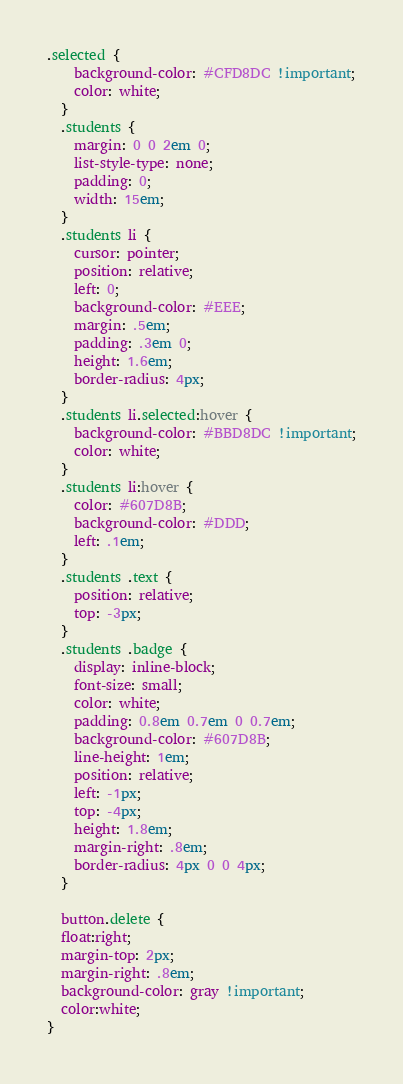<code> <loc_0><loc_0><loc_500><loc_500><_CSS_>.selected {
    background-color: #CFD8DC !important;
    color: white;
  }
  .students {
    margin: 0 0 2em 0;
    list-style-type: none;
    padding: 0;
    width: 15em;
  }
  .students li {
    cursor: pointer;
    position: relative;
    left: 0;
    background-color: #EEE;
    margin: .5em;
    padding: .3em 0;
    height: 1.6em;
    border-radius: 4px;
  }
  .students li.selected:hover {
    background-color: #BBD8DC !important;
    color: white;
  }
  .students li:hover {
    color: #607D8B;
    background-color: #DDD;
    left: .1em;
  }
  .students .text {
    position: relative;
    top: -3px;
  }
  .students .badge {
    display: inline-block;
    font-size: small;
    color: white;
    padding: 0.8em 0.7em 0 0.7em;
    background-color: #607D8B;
    line-height: 1em;
    position: relative;
    left: -1px;
    top: -4px;
    height: 1.8em;
    margin-right: .8em;
    border-radius: 4px 0 0 4px;
  }

  button.delete {
  float:right;
  margin-top: 2px;
  margin-right: .8em;
  background-color: gray !important;
  color:white;
}</code> 